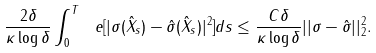Convert formula to latex. <formula><loc_0><loc_0><loc_500><loc_500>\frac { 2 \delta } { \kappa \log \delta } \int _ { 0 } ^ { T } \ e [ | { \sigma } ( \hat { X } _ { s } ) - \hat { \sigma } ( \hat { X } _ { s } ) | ^ { 2 } ] d s \leq \frac { C \delta } { \kappa \log \delta } | | \sigma - \hat { \sigma } | | _ { 2 } ^ { 2 } .</formula> 